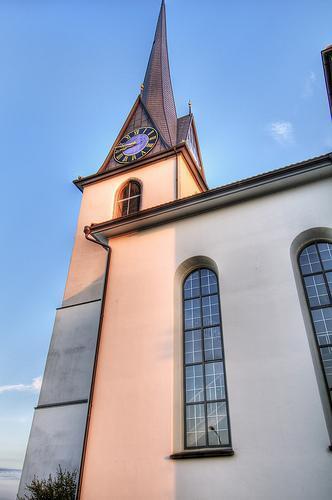How many clocks are there?
Give a very brief answer. 1. 